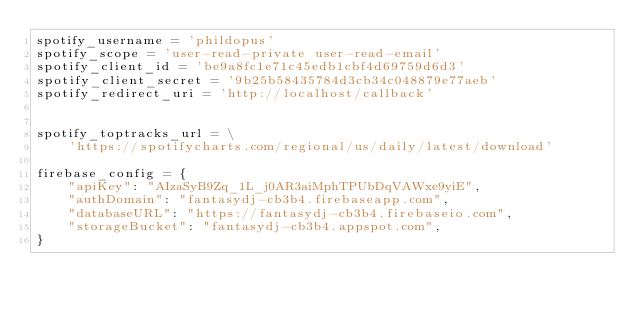<code> <loc_0><loc_0><loc_500><loc_500><_Python_>spotify_username = 'phildopus'
spotify_scope = 'user-read-private user-read-email'
spotify_client_id = 'be9a8fc1e71c45edb1cbf4d69759d6d3'
spotify_client_secret = '9b25b58435784d3cb34c048879e77aeb'
spotify_redirect_uri = 'http://localhost/callback'


spotify_toptracks_url = \
    'https://spotifycharts.com/regional/us/daily/latest/download'

firebase_config = {
    "apiKey": "AIzaSyB9Zq_1L_j0AR3aiMphTPUbDqVAWxe9yiE",
    "authDomain": "fantasydj-cb3b4.firebaseapp.com",
    "databaseURL": "https://fantasydj-cb3b4.firebaseio.com",
    "storageBucket": "fantasydj-cb3b4.appspot.com",
}
</code> 